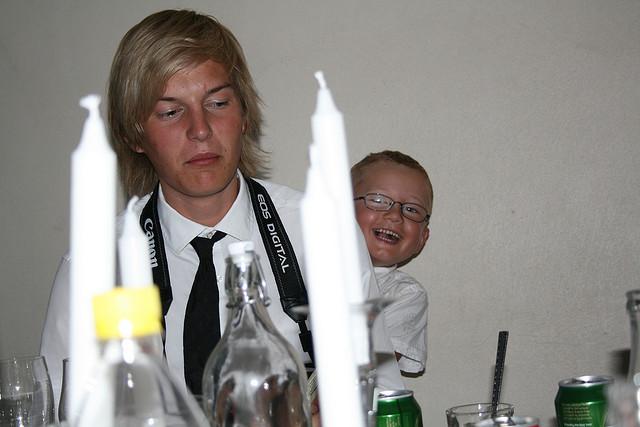Are the candles lit?
Answer briefly. No. Are boys the same age?
Keep it brief. No. Who has the glasses?
Answer briefly. Boy. 